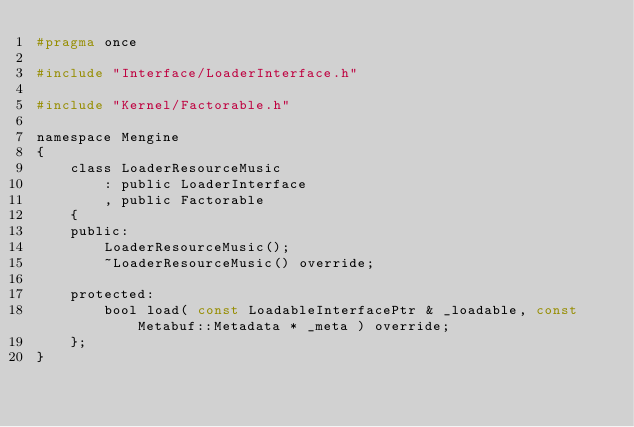Convert code to text. <code><loc_0><loc_0><loc_500><loc_500><_C_>#pragma once

#include "Interface/LoaderInterface.h"

#include "Kernel/Factorable.h"

namespace Mengine
{
    class LoaderResourceMusic
        : public LoaderInterface
        , public Factorable
    {
    public:
        LoaderResourceMusic();
        ~LoaderResourceMusic() override;

    protected:
        bool load( const LoadableInterfacePtr & _loadable, const Metabuf::Metadata * _meta ) override;
    };
}
</code> 